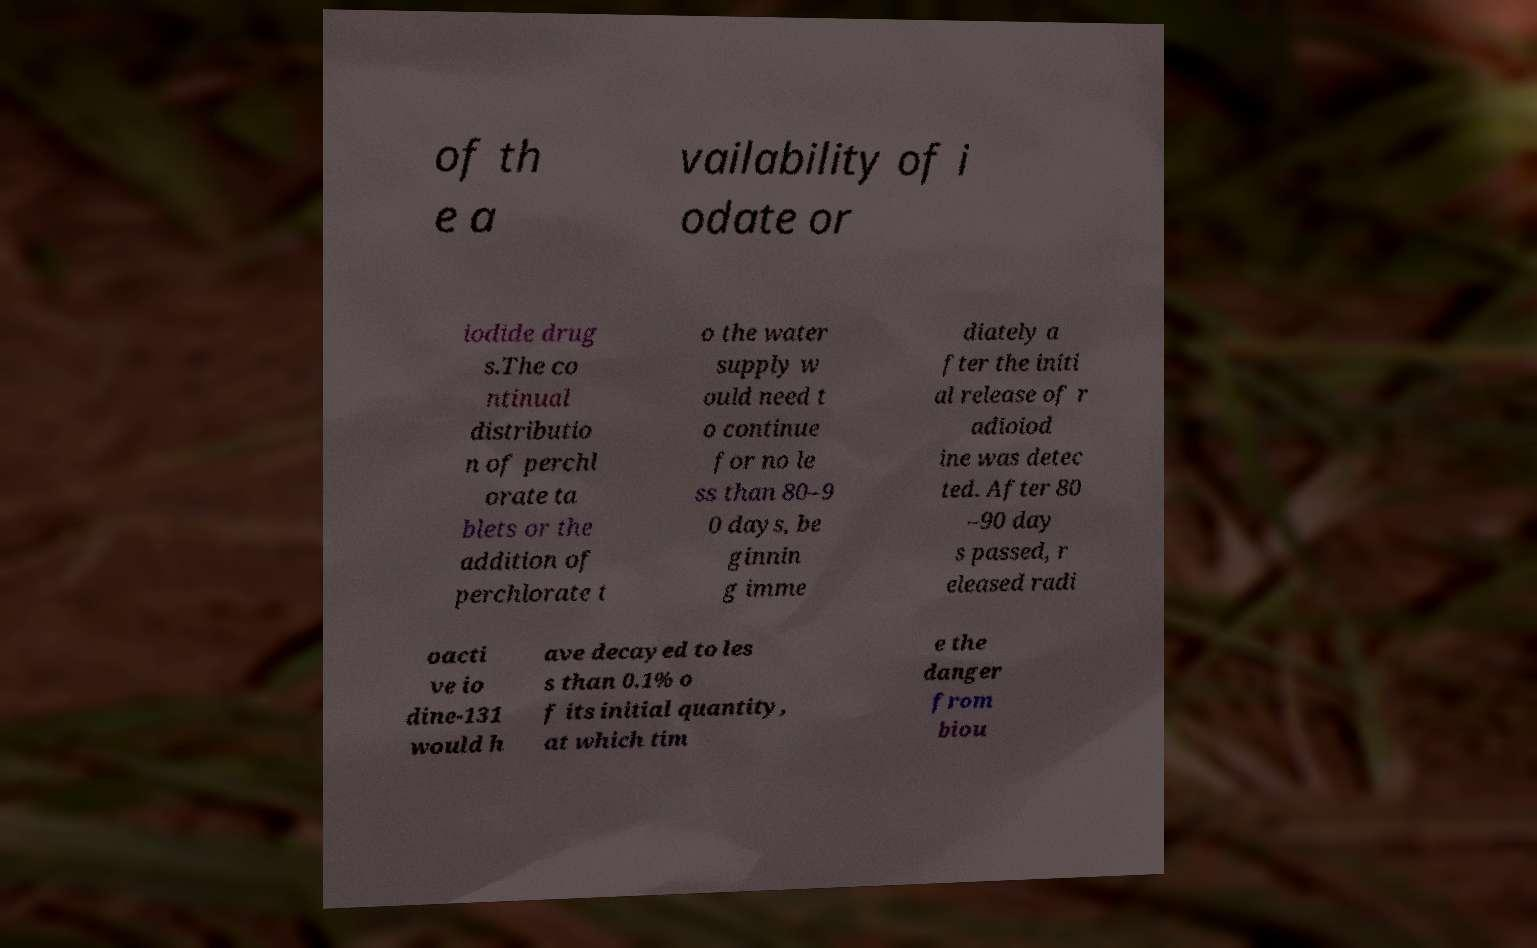Please read and relay the text visible in this image. What does it say? of th e a vailability of i odate or iodide drug s.The co ntinual distributio n of perchl orate ta blets or the addition of perchlorate t o the water supply w ould need t o continue for no le ss than 80–9 0 days, be ginnin g imme diately a fter the initi al release of r adioiod ine was detec ted. After 80 –90 day s passed, r eleased radi oacti ve io dine-131 would h ave decayed to les s than 0.1% o f its initial quantity, at which tim e the danger from biou 